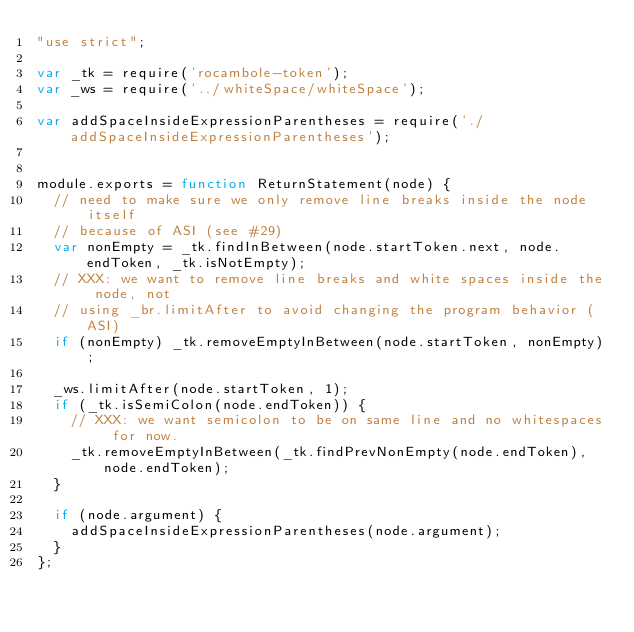Convert code to text. <code><loc_0><loc_0><loc_500><loc_500><_JavaScript_>"use strict";

var _tk = require('rocambole-token');
var _ws = require('../whiteSpace/whiteSpace');

var addSpaceInsideExpressionParentheses = require('./addSpaceInsideExpressionParentheses');


module.exports = function ReturnStatement(node) {
  // need to make sure we only remove line breaks inside the node itself
  // because of ASI (see #29)
  var nonEmpty = _tk.findInBetween(node.startToken.next, node.endToken, _tk.isNotEmpty);
  // XXX: we want to remove line breaks and white spaces inside the node, not
  // using _br.limitAfter to avoid changing the program behavior (ASI)
  if (nonEmpty) _tk.removeEmptyInBetween(node.startToken, nonEmpty);

  _ws.limitAfter(node.startToken, 1);
  if (_tk.isSemiColon(node.endToken)) {
    // XXX: we want semicolon to be on same line and no whitespaces for now.
    _tk.removeEmptyInBetween(_tk.findPrevNonEmpty(node.endToken), node.endToken);
  }

  if (node.argument) {
    addSpaceInsideExpressionParentheses(node.argument);
  }
};
</code> 